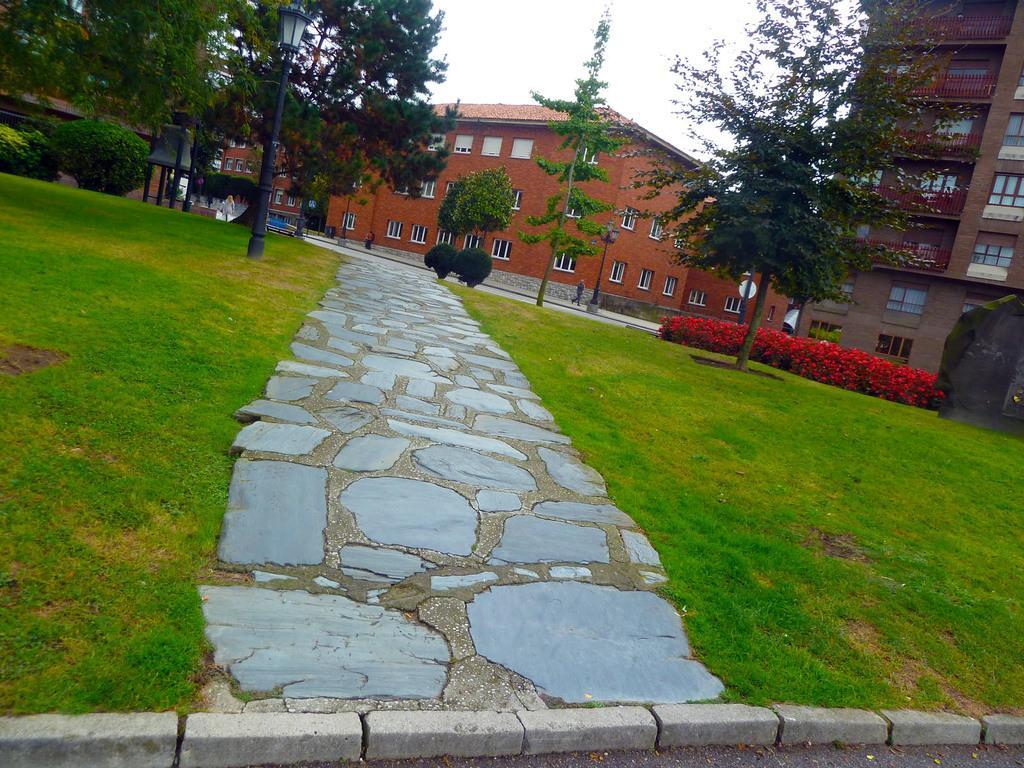Can you describe this image briefly? In this image at the bottom there is grass and walkway, and in the background there are some trees, houses, poles and some plants and flowers. And at the top of the image there is sky. 